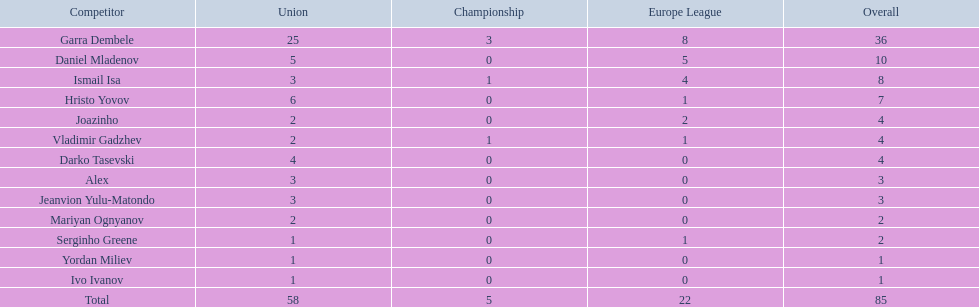Who is a player in the same league as both joazinho and vladimir gadzhev? Mariyan Ognyanov. 